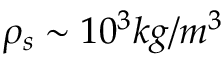<formula> <loc_0><loc_0><loc_500><loc_500>\rho _ { s } \sim 1 0 ^ { 3 } k g / m ^ { 3 }</formula> 